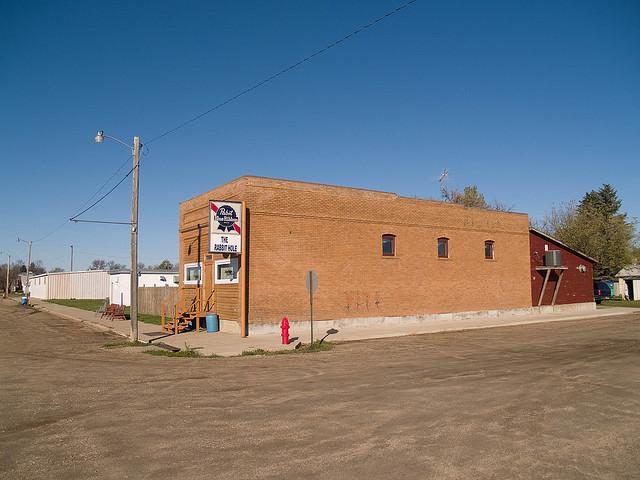How many yard are there humps?
Write a very short answer. 0. What is the date?
Write a very short answer. June. What time was the photo taken?
Answer briefly. Daytime. What is leaning against the house?
Give a very brief answer. Nothing. What does the sign say?
Quick response, please. Pabst blue ribbon. Is there a meter in the picture?
Answer briefly. No. Are there train tracks nearby?
Write a very short answer. No. Is the square empty?
Short answer required. Yes. What is on the white banner?
Keep it brief. Pabst blue ribbon. What is the logo?
Answer briefly. Pabst blue ribbon. Are there any steps in this photo?
Give a very brief answer. Yes. Is that building made out of bricks?
Give a very brief answer. Yes. Why is the hydraulic pump on the street?
Give a very brief answer. Fire. Is the building large?
Short answer required. No. Is it a rainy day?
Answer briefly. No. What color is the building?
Write a very short answer. Brown. Is the sun in the sky?
Answer briefly. Yes. What sign is on the street ground?
Be succinct. Stop. Is the hydrant between buildings?
Quick response, please. No. Is there a container garden?
Keep it brief. No. How many cars are in the picture?
Answer briefly. 0. What can you buy here?
Short answer required. Beer. 